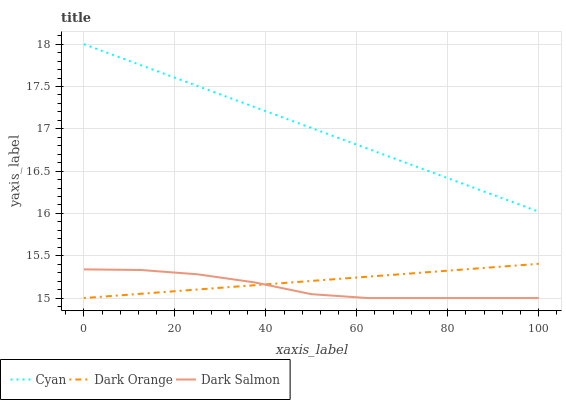Does Dark Salmon have the minimum area under the curve?
Answer yes or no. Yes. Does Cyan have the maximum area under the curve?
Answer yes or no. Yes. Does Dark Orange have the minimum area under the curve?
Answer yes or no. No. Does Dark Orange have the maximum area under the curve?
Answer yes or no. No. Is Dark Orange the smoothest?
Answer yes or no. Yes. Is Dark Salmon the roughest?
Answer yes or no. Yes. Is Dark Salmon the smoothest?
Answer yes or no. No. Is Dark Orange the roughest?
Answer yes or no. No. Does Dark Salmon have the lowest value?
Answer yes or no. Yes. Does Cyan have the highest value?
Answer yes or no. Yes. Does Dark Orange have the highest value?
Answer yes or no. No. Is Dark Orange less than Cyan?
Answer yes or no. Yes. Is Cyan greater than Dark Orange?
Answer yes or no. Yes. Does Dark Salmon intersect Dark Orange?
Answer yes or no. Yes. Is Dark Salmon less than Dark Orange?
Answer yes or no. No. Is Dark Salmon greater than Dark Orange?
Answer yes or no. No. Does Dark Orange intersect Cyan?
Answer yes or no. No. 